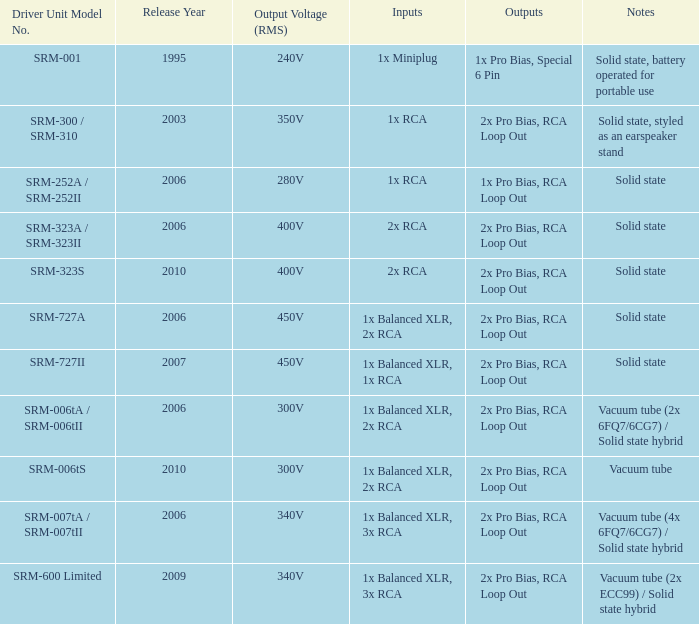When were the 2x pro bias, rca loop out, and vacuum tube notes functionalities released? 2010.0. Give me the full table as a dictionary. {'header': ['Driver Unit Model No.', 'Release Year', 'Output Voltage (RMS)', 'Inputs', 'Outputs', 'Notes'], 'rows': [['SRM-001', '1995', '240V', '1x Miniplug', '1x Pro Bias, Special 6 Pin', 'Solid state, battery operated for portable use'], ['SRM-300 / SRM-310', '2003', '350V', '1x RCA', '2x Pro Bias, RCA Loop Out', 'Solid state, styled as an earspeaker stand'], ['SRM-252A / SRM-252II', '2006', '280V', '1x RCA', '1x Pro Bias, RCA Loop Out', 'Solid state'], ['SRM-323A / SRM-323II', '2006', '400V', '2x RCA', '2x Pro Bias, RCA Loop Out', 'Solid state'], ['SRM-323S', '2010', '400V', '2x RCA', '2x Pro Bias, RCA Loop Out', 'Solid state'], ['SRM-727A', '2006', '450V', '1x Balanced XLR, 2x RCA', '2x Pro Bias, RCA Loop Out', 'Solid state'], ['SRM-727II', '2007', '450V', '1x Balanced XLR, 1x RCA', '2x Pro Bias, RCA Loop Out', 'Solid state'], ['SRM-006tA / SRM-006tII', '2006', '300V', '1x Balanced XLR, 2x RCA', '2x Pro Bias, RCA Loop Out', 'Vacuum tube (2x 6FQ7/6CG7) / Solid state hybrid'], ['SRM-006tS', '2010', '300V', '1x Balanced XLR, 2x RCA', '2x Pro Bias, RCA Loop Out', 'Vacuum tube'], ['SRM-007tA / SRM-007tII', '2006', '340V', '1x Balanced XLR, 3x RCA', '2x Pro Bias, RCA Loop Out', 'Vacuum tube (4x 6FQ7/6CG7) / Solid state hybrid'], ['SRM-600 Limited', '2009', '340V', '1x Balanced XLR, 3x RCA', '2x Pro Bias, RCA Loop Out', 'Vacuum tube (2x ECC99) / Solid state hybrid']]} 